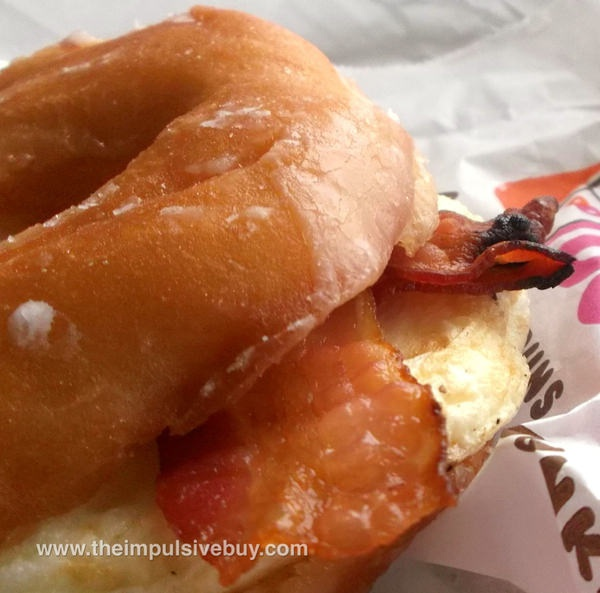Describe the objects in this image and their specific colors. I can see donut in lightgray, maroon, brown, and tan tones and donut in lightgray, brown, maroon, and tan tones in this image. 